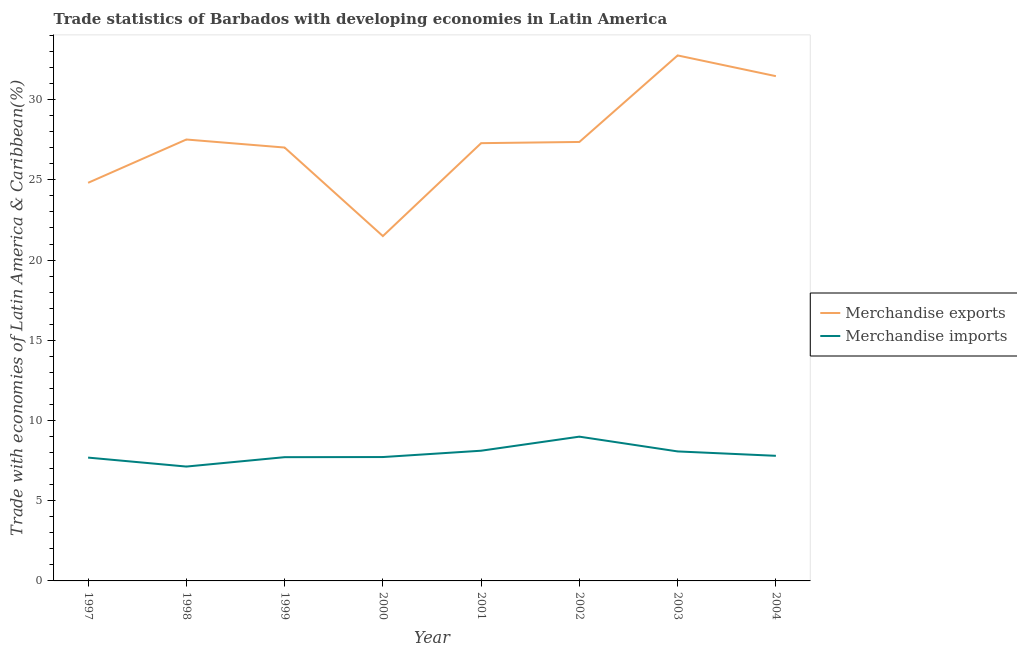What is the merchandise exports in 2001?
Provide a short and direct response. 27.29. Across all years, what is the maximum merchandise imports?
Your answer should be very brief. 8.99. Across all years, what is the minimum merchandise imports?
Keep it short and to the point. 7.13. In which year was the merchandise exports minimum?
Your answer should be very brief. 2000. What is the total merchandise exports in the graph?
Make the answer very short. 219.72. What is the difference between the merchandise imports in 1999 and that in 2004?
Provide a succinct answer. -0.08. What is the difference between the merchandise imports in 1999 and the merchandise exports in 2000?
Make the answer very short. -13.78. What is the average merchandise exports per year?
Offer a very short reply. 27.46. In the year 2002, what is the difference between the merchandise imports and merchandise exports?
Your response must be concise. -18.37. In how many years, is the merchandise exports greater than 21 %?
Provide a succinct answer. 8. What is the ratio of the merchandise imports in 1997 to that in 2004?
Provide a succinct answer. 0.99. Is the merchandise imports in 1997 less than that in 1999?
Make the answer very short. Yes. What is the difference between the highest and the second highest merchandise exports?
Offer a terse response. 1.29. What is the difference between the highest and the lowest merchandise imports?
Keep it short and to the point. 1.86. In how many years, is the merchandise imports greater than the average merchandise imports taken over all years?
Your answer should be compact. 3. Does the merchandise exports monotonically increase over the years?
Provide a short and direct response. No. Is the merchandise exports strictly greater than the merchandise imports over the years?
Offer a terse response. Yes. How many lines are there?
Ensure brevity in your answer.  2. How many years are there in the graph?
Keep it short and to the point. 8. Does the graph contain grids?
Your answer should be compact. No. What is the title of the graph?
Provide a succinct answer. Trade statistics of Barbados with developing economies in Latin America. Does "Food" appear as one of the legend labels in the graph?
Offer a very short reply. No. What is the label or title of the Y-axis?
Offer a very short reply. Trade with economies of Latin America & Caribbean(%). What is the Trade with economies of Latin America & Caribbean(%) in Merchandise exports in 1997?
Your response must be concise. 24.82. What is the Trade with economies of Latin America & Caribbean(%) of Merchandise imports in 1997?
Ensure brevity in your answer.  7.69. What is the Trade with economies of Latin America & Caribbean(%) of Merchandise exports in 1998?
Make the answer very short. 27.52. What is the Trade with economies of Latin America & Caribbean(%) in Merchandise imports in 1998?
Offer a terse response. 7.13. What is the Trade with economies of Latin America & Caribbean(%) in Merchandise exports in 1999?
Offer a very short reply. 27.02. What is the Trade with economies of Latin America & Caribbean(%) of Merchandise imports in 1999?
Provide a short and direct response. 7.71. What is the Trade with economies of Latin America & Caribbean(%) in Merchandise exports in 2000?
Offer a very short reply. 21.5. What is the Trade with economies of Latin America & Caribbean(%) in Merchandise imports in 2000?
Ensure brevity in your answer.  7.72. What is the Trade with economies of Latin America & Caribbean(%) in Merchandise exports in 2001?
Provide a succinct answer. 27.29. What is the Trade with economies of Latin America & Caribbean(%) in Merchandise imports in 2001?
Ensure brevity in your answer.  8.12. What is the Trade with economies of Latin America & Caribbean(%) in Merchandise exports in 2002?
Make the answer very short. 27.36. What is the Trade with economies of Latin America & Caribbean(%) of Merchandise imports in 2002?
Your answer should be compact. 8.99. What is the Trade with economies of Latin America & Caribbean(%) in Merchandise exports in 2003?
Offer a very short reply. 32.76. What is the Trade with economies of Latin America & Caribbean(%) in Merchandise imports in 2003?
Your answer should be very brief. 8.07. What is the Trade with economies of Latin America & Caribbean(%) of Merchandise exports in 2004?
Provide a succinct answer. 31.46. What is the Trade with economies of Latin America & Caribbean(%) of Merchandise imports in 2004?
Your response must be concise. 7.8. Across all years, what is the maximum Trade with economies of Latin America & Caribbean(%) in Merchandise exports?
Provide a short and direct response. 32.76. Across all years, what is the maximum Trade with economies of Latin America & Caribbean(%) of Merchandise imports?
Ensure brevity in your answer.  8.99. Across all years, what is the minimum Trade with economies of Latin America & Caribbean(%) of Merchandise exports?
Keep it short and to the point. 21.5. Across all years, what is the minimum Trade with economies of Latin America & Caribbean(%) in Merchandise imports?
Your answer should be very brief. 7.13. What is the total Trade with economies of Latin America & Caribbean(%) of Merchandise exports in the graph?
Your answer should be compact. 219.72. What is the total Trade with economies of Latin America & Caribbean(%) in Merchandise imports in the graph?
Your answer should be very brief. 63.23. What is the difference between the Trade with economies of Latin America & Caribbean(%) in Merchandise exports in 1997 and that in 1998?
Give a very brief answer. -2.7. What is the difference between the Trade with economies of Latin America & Caribbean(%) of Merchandise imports in 1997 and that in 1998?
Ensure brevity in your answer.  0.56. What is the difference between the Trade with economies of Latin America & Caribbean(%) in Merchandise exports in 1997 and that in 1999?
Provide a short and direct response. -2.2. What is the difference between the Trade with economies of Latin America & Caribbean(%) in Merchandise imports in 1997 and that in 1999?
Offer a very short reply. -0.03. What is the difference between the Trade with economies of Latin America & Caribbean(%) in Merchandise exports in 1997 and that in 2000?
Keep it short and to the point. 3.32. What is the difference between the Trade with economies of Latin America & Caribbean(%) in Merchandise imports in 1997 and that in 2000?
Provide a succinct answer. -0.03. What is the difference between the Trade with economies of Latin America & Caribbean(%) of Merchandise exports in 1997 and that in 2001?
Your answer should be compact. -2.47. What is the difference between the Trade with economies of Latin America & Caribbean(%) in Merchandise imports in 1997 and that in 2001?
Your answer should be compact. -0.43. What is the difference between the Trade with economies of Latin America & Caribbean(%) of Merchandise exports in 1997 and that in 2002?
Ensure brevity in your answer.  -2.55. What is the difference between the Trade with economies of Latin America & Caribbean(%) in Merchandise imports in 1997 and that in 2002?
Provide a succinct answer. -1.31. What is the difference between the Trade with economies of Latin America & Caribbean(%) in Merchandise exports in 1997 and that in 2003?
Make the answer very short. -7.94. What is the difference between the Trade with economies of Latin America & Caribbean(%) of Merchandise imports in 1997 and that in 2003?
Offer a terse response. -0.39. What is the difference between the Trade with economies of Latin America & Caribbean(%) in Merchandise exports in 1997 and that in 2004?
Keep it short and to the point. -6.65. What is the difference between the Trade with economies of Latin America & Caribbean(%) in Merchandise imports in 1997 and that in 2004?
Your answer should be very brief. -0.11. What is the difference between the Trade with economies of Latin America & Caribbean(%) in Merchandise exports in 1998 and that in 1999?
Give a very brief answer. 0.5. What is the difference between the Trade with economies of Latin America & Caribbean(%) in Merchandise imports in 1998 and that in 1999?
Provide a short and direct response. -0.59. What is the difference between the Trade with economies of Latin America & Caribbean(%) of Merchandise exports in 1998 and that in 2000?
Provide a succinct answer. 6.02. What is the difference between the Trade with economies of Latin America & Caribbean(%) in Merchandise imports in 1998 and that in 2000?
Offer a terse response. -0.59. What is the difference between the Trade with economies of Latin America & Caribbean(%) in Merchandise exports in 1998 and that in 2001?
Make the answer very short. 0.23. What is the difference between the Trade with economies of Latin America & Caribbean(%) in Merchandise imports in 1998 and that in 2001?
Make the answer very short. -0.99. What is the difference between the Trade with economies of Latin America & Caribbean(%) in Merchandise exports in 1998 and that in 2002?
Offer a terse response. 0.15. What is the difference between the Trade with economies of Latin America & Caribbean(%) of Merchandise imports in 1998 and that in 2002?
Offer a very short reply. -1.86. What is the difference between the Trade with economies of Latin America & Caribbean(%) in Merchandise exports in 1998 and that in 2003?
Your answer should be very brief. -5.24. What is the difference between the Trade with economies of Latin America & Caribbean(%) of Merchandise imports in 1998 and that in 2003?
Your response must be concise. -0.94. What is the difference between the Trade with economies of Latin America & Caribbean(%) of Merchandise exports in 1998 and that in 2004?
Provide a short and direct response. -3.95. What is the difference between the Trade with economies of Latin America & Caribbean(%) in Merchandise imports in 1998 and that in 2004?
Keep it short and to the point. -0.67. What is the difference between the Trade with economies of Latin America & Caribbean(%) in Merchandise exports in 1999 and that in 2000?
Your response must be concise. 5.52. What is the difference between the Trade with economies of Latin America & Caribbean(%) of Merchandise imports in 1999 and that in 2000?
Provide a short and direct response. -0.01. What is the difference between the Trade with economies of Latin America & Caribbean(%) in Merchandise exports in 1999 and that in 2001?
Provide a short and direct response. -0.27. What is the difference between the Trade with economies of Latin America & Caribbean(%) in Merchandise imports in 1999 and that in 2001?
Offer a terse response. -0.4. What is the difference between the Trade with economies of Latin America & Caribbean(%) in Merchandise exports in 1999 and that in 2002?
Give a very brief answer. -0.35. What is the difference between the Trade with economies of Latin America & Caribbean(%) in Merchandise imports in 1999 and that in 2002?
Keep it short and to the point. -1.28. What is the difference between the Trade with economies of Latin America & Caribbean(%) of Merchandise exports in 1999 and that in 2003?
Make the answer very short. -5.74. What is the difference between the Trade with economies of Latin America & Caribbean(%) of Merchandise imports in 1999 and that in 2003?
Ensure brevity in your answer.  -0.36. What is the difference between the Trade with economies of Latin America & Caribbean(%) in Merchandise exports in 1999 and that in 2004?
Ensure brevity in your answer.  -4.45. What is the difference between the Trade with economies of Latin America & Caribbean(%) of Merchandise imports in 1999 and that in 2004?
Make the answer very short. -0.08. What is the difference between the Trade with economies of Latin America & Caribbean(%) in Merchandise exports in 2000 and that in 2001?
Your answer should be compact. -5.79. What is the difference between the Trade with economies of Latin America & Caribbean(%) of Merchandise imports in 2000 and that in 2001?
Keep it short and to the point. -0.39. What is the difference between the Trade with economies of Latin America & Caribbean(%) of Merchandise exports in 2000 and that in 2002?
Make the answer very short. -5.87. What is the difference between the Trade with economies of Latin America & Caribbean(%) of Merchandise imports in 2000 and that in 2002?
Give a very brief answer. -1.27. What is the difference between the Trade with economies of Latin America & Caribbean(%) in Merchandise exports in 2000 and that in 2003?
Keep it short and to the point. -11.26. What is the difference between the Trade with economies of Latin America & Caribbean(%) of Merchandise imports in 2000 and that in 2003?
Give a very brief answer. -0.35. What is the difference between the Trade with economies of Latin America & Caribbean(%) in Merchandise exports in 2000 and that in 2004?
Your answer should be compact. -9.97. What is the difference between the Trade with economies of Latin America & Caribbean(%) in Merchandise imports in 2000 and that in 2004?
Your answer should be compact. -0.08. What is the difference between the Trade with economies of Latin America & Caribbean(%) in Merchandise exports in 2001 and that in 2002?
Your response must be concise. -0.07. What is the difference between the Trade with economies of Latin America & Caribbean(%) in Merchandise imports in 2001 and that in 2002?
Make the answer very short. -0.88. What is the difference between the Trade with economies of Latin America & Caribbean(%) of Merchandise exports in 2001 and that in 2003?
Provide a short and direct response. -5.47. What is the difference between the Trade with economies of Latin America & Caribbean(%) in Merchandise imports in 2001 and that in 2003?
Offer a very short reply. 0.04. What is the difference between the Trade with economies of Latin America & Caribbean(%) of Merchandise exports in 2001 and that in 2004?
Your answer should be very brief. -4.18. What is the difference between the Trade with economies of Latin America & Caribbean(%) of Merchandise imports in 2001 and that in 2004?
Provide a short and direct response. 0.32. What is the difference between the Trade with economies of Latin America & Caribbean(%) in Merchandise exports in 2002 and that in 2003?
Keep it short and to the point. -5.39. What is the difference between the Trade with economies of Latin America & Caribbean(%) in Merchandise imports in 2002 and that in 2003?
Make the answer very short. 0.92. What is the difference between the Trade with economies of Latin America & Caribbean(%) in Merchandise exports in 2002 and that in 2004?
Give a very brief answer. -4.1. What is the difference between the Trade with economies of Latin America & Caribbean(%) in Merchandise imports in 2002 and that in 2004?
Your answer should be very brief. 1.19. What is the difference between the Trade with economies of Latin America & Caribbean(%) of Merchandise exports in 2003 and that in 2004?
Your response must be concise. 1.29. What is the difference between the Trade with economies of Latin America & Caribbean(%) in Merchandise imports in 2003 and that in 2004?
Keep it short and to the point. 0.27. What is the difference between the Trade with economies of Latin America & Caribbean(%) of Merchandise exports in 1997 and the Trade with economies of Latin America & Caribbean(%) of Merchandise imports in 1998?
Provide a short and direct response. 17.69. What is the difference between the Trade with economies of Latin America & Caribbean(%) of Merchandise exports in 1997 and the Trade with economies of Latin America & Caribbean(%) of Merchandise imports in 1999?
Your response must be concise. 17.1. What is the difference between the Trade with economies of Latin America & Caribbean(%) in Merchandise exports in 1997 and the Trade with economies of Latin America & Caribbean(%) in Merchandise imports in 2000?
Offer a terse response. 17.09. What is the difference between the Trade with economies of Latin America & Caribbean(%) in Merchandise exports in 1997 and the Trade with economies of Latin America & Caribbean(%) in Merchandise imports in 2001?
Offer a terse response. 16.7. What is the difference between the Trade with economies of Latin America & Caribbean(%) in Merchandise exports in 1997 and the Trade with economies of Latin America & Caribbean(%) in Merchandise imports in 2002?
Provide a short and direct response. 15.82. What is the difference between the Trade with economies of Latin America & Caribbean(%) in Merchandise exports in 1997 and the Trade with economies of Latin America & Caribbean(%) in Merchandise imports in 2003?
Your answer should be compact. 16.74. What is the difference between the Trade with economies of Latin America & Caribbean(%) of Merchandise exports in 1997 and the Trade with economies of Latin America & Caribbean(%) of Merchandise imports in 2004?
Offer a very short reply. 17.02. What is the difference between the Trade with economies of Latin America & Caribbean(%) of Merchandise exports in 1998 and the Trade with economies of Latin America & Caribbean(%) of Merchandise imports in 1999?
Your answer should be very brief. 19.8. What is the difference between the Trade with economies of Latin America & Caribbean(%) in Merchandise exports in 1998 and the Trade with economies of Latin America & Caribbean(%) in Merchandise imports in 2000?
Provide a succinct answer. 19.79. What is the difference between the Trade with economies of Latin America & Caribbean(%) of Merchandise exports in 1998 and the Trade with economies of Latin America & Caribbean(%) of Merchandise imports in 2001?
Offer a very short reply. 19.4. What is the difference between the Trade with economies of Latin America & Caribbean(%) in Merchandise exports in 1998 and the Trade with economies of Latin America & Caribbean(%) in Merchandise imports in 2002?
Your answer should be very brief. 18.52. What is the difference between the Trade with economies of Latin America & Caribbean(%) of Merchandise exports in 1998 and the Trade with economies of Latin America & Caribbean(%) of Merchandise imports in 2003?
Your answer should be compact. 19.44. What is the difference between the Trade with economies of Latin America & Caribbean(%) in Merchandise exports in 1998 and the Trade with economies of Latin America & Caribbean(%) in Merchandise imports in 2004?
Your answer should be compact. 19.72. What is the difference between the Trade with economies of Latin America & Caribbean(%) of Merchandise exports in 1999 and the Trade with economies of Latin America & Caribbean(%) of Merchandise imports in 2000?
Your answer should be compact. 19.29. What is the difference between the Trade with economies of Latin America & Caribbean(%) in Merchandise exports in 1999 and the Trade with economies of Latin America & Caribbean(%) in Merchandise imports in 2001?
Offer a very short reply. 18.9. What is the difference between the Trade with economies of Latin America & Caribbean(%) of Merchandise exports in 1999 and the Trade with economies of Latin America & Caribbean(%) of Merchandise imports in 2002?
Provide a succinct answer. 18.02. What is the difference between the Trade with economies of Latin America & Caribbean(%) in Merchandise exports in 1999 and the Trade with economies of Latin America & Caribbean(%) in Merchandise imports in 2003?
Make the answer very short. 18.94. What is the difference between the Trade with economies of Latin America & Caribbean(%) in Merchandise exports in 1999 and the Trade with economies of Latin America & Caribbean(%) in Merchandise imports in 2004?
Provide a short and direct response. 19.22. What is the difference between the Trade with economies of Latin America & Caribbean(%) in Merchandise exports in 2000 and the Trade with economies of Latin America & Caribbean(%) in Merchandise imports in 2001?
Provide a succinct answer. 13.38. What is the difference between the Trade with economies of Latin America & Caribbean(%) in Merchandise exports in 2000 and the Trade with economies of Latin America & Caribbean(%) in Merchandise imports in 2002?
Give a very brief answer. 12.5. What is the difference between the Trade with economies of Latin America & Caribbean(%) of Merchandise exports in 2000 and the Trade with economies of Latin America & Caribbean(%) of Merchandise imports in 2003?
Keep it short and to the point. 13.42. What is the difference between the Trade with economies of Latin America & Caribbean(%) in Merchandise exports in 2000 and the Trade with economies of Latin America & Caribbean(%) in Merchandise imports in 2004?
Your answer should be compact. 13.7. What is the difference between the Trade with economies of Latin America & Caribbean(%) in Merchandise exports in 2001 and the Trade with economies of Latin America & Caribbean(%) in Merchandise imports in 2002?
Your response must be concise. 18.3. What is the difference between the Trade with economies of Latin America & Caribbean(%) of Merchandise exports in 2001 and the Trade with economies of Latin America & Caribbean(%) of Merchandise imports in 2003?
Provide a succinct answer. 19.22. What is the difference between the Trade with economies of Latin America & Caribbean(%) in Merchandise exports in 2001 and the Trade with economies of Latin America & Caribbean(%) in Merchandise imports in 2004?
Keep it short and to the point. 19.49. What is the difference between the Trade with economies of Latin America & Caribbean(%) in Merchandise exports in 2002 and the Trade with economies of Latin America & Caribbean(%) in Merchandise imports in 2003?
Keep it short and to the point. 19.29. What is the difference between the Trade with economies of Latin America & Caribbean(%) of Merchandise exports in 2002 and the Trade with economies of Latin America & Caribbean(%) of Merchandise imports in 2004?
Offer a very short reply. 19.57. What is the difference between the Trade with economies of Latin America & Caribbean(%) of Merchandise exports in 2003 and the Trade with economies of Latin America & Caribbean(%) of Merchandise imports in 2004?
Your response must be concise. 24.96. What is the average Trade with economies of Latin America & Caribbean(%) in Merchandise exports per year?
Give a very brief answer. 27.46. What is the average Trade with economies of Latin America & Caribbean(%) of Merchandise imports per year?
Ensure brevity in your answer.  7.9. In the year 1997, what is the difference between the Trade with economies of Latin America & Caribbean(%) of Merchandise exports and Trade with economies of Latin America & Caribbean(%) of Merchandise imports?
Your response must be concise. 17.13. In the year 1998, what is the difference between the Trade with economies of Latin America & Caribbean(%) of Merchandise exports and Trade with economies of Latin America & Caribbean(%) of Merchandise imports?
Provide a short and direct response. 20.39. In the year 1999, what is the difference between the Trade with economies of Latin America & Caribbean(%) of Merchandise exports and Trade with economies of Latin America & Caribbean(%) of Merchandise imports?
Ensure brevity in your answer.  19.3. In the year 2000, what is the difference between the Trade with economies of Latin America & Caribbean(%) in Merchandise exports and Trade with economies of Latin America & Caribbean(%) in Merchandise imports?
Your response must be concise. 13.77. In the year 2001, what is the difference between the Trade with economies of Latin America & Caribbean(%) in Merchandise exports and Trade with economies of Latin America & Caribbean(%) in Merchandise imports?
Give a very brief answer. 19.17. In the year 2002, what is the difference between the Trade with economies of Latin America & Caribbean(%) in Merchandise exports and Trade with economies of Latin America & Caribbean(%) in Merchandise imports?
Provide a short and direct response. 18.37. In the year 2003, what is the difference between the Trade with economies of Latin America & Caribbean(%) in Merchandise exports and Trade with economies of Latin America & Caribbean(%) in Merchandise imports?
Your answer should be compact. 24.68. In the year 2004, what is the difference between the Trade with economies of Latin America & Caribbean(%) in Merchandise exports and Trade with economies of Latin America & Caribbean(%) in Merchandise imports?
Provide a succinct answer. 23.67. What is the ratio of the Trade with economies of Latin America & Caribbean(%) in Merchandise exports in 1997 to that in 1998?
Give a very brief answer. 0.9. What is the ratio of the Trade with economies of Latin America & Caribbean(%) in Merchandise imports in 1997 to that in 1998?
Make the answer very short. 1.08. What is the ratio of the Trade with economies of Latin America & Caribbean(%) of Merchandise exports in 1997 to that in 1999?
Your answer should be very brief. 0.92. What is the ratio of the Trade with economies of Latin America & Caribbean(%) of Merchandise exports in 1997 to that in 2000?
Keep it short and to the point. 1.15. What is the ratio of the Trade with economies of Latin America & Caribbean(%) in Merchandise exports in 1997 to that in 2001?
Make the answer very short. 0.91. What is the ratio of the Trade with economies of Latin America & Caribbean(%) of Merchandise imports in 1997 to that in 2001?
Your answer should be compact. 0.95. What is the ratio of the Trade with economies of Latin America & Caribbean(%) in Merchandise exports in 1997 to that in 2002?
Offer a terse response. 0.91. What is the ratio of the Trade with economies of Latin America & Caribbean(%) in Merchandise imports in 1997 to that in 2002?
Your answer should be compact. 0.85. What is the ratio of the Trade with economies of Latin America & Caribbean(%) in Merchandise exports in 1997 to that in 2003?
Ensure brevity in your answer.  0.76. What is the ratio of the Trade with economies of Latin America & Caribbean(%) in Merchandise imports in 1997 to that in 2003?
Your answer should be compact. 0.95. What is the ratio of the Trade with economies of Latin America & Caribbean(%) of Merchandise exports in 1997 to that in 2004?
Keep it short and to the point. 0.79. What is the ratio of the Trade with economies of Latin America & Caribbean(%) in Merchandise imports in 1997 to that in 2004?
Offer a terse response. 0.99. What is the ratio of the Trade with economies of Latin America & Caribbean(%) of Merchandise exports in 1998 to that in 1999?
Ensure brevity in your answer.  1.02. What is the ratio of the Trade with economies of Latin America & Caribbean(%) of Merchandise imports in 1998 to that in 1999?
Offer a very short reply. 0.92. What is the ratio of the Trade with economies of Latin America & Caribbean(%) in Merchandise exports in 1998 to that in 2000?
Your answer should be compact. 1.28. What is the ratio of the Trade with economies of Latin America & Caribbean(%) in Merchandise imports in 1998 to that in 2000?
Your response must be concise. 0.92. What is the ratio of the Trade with economies of Latin America & Caribbean(%) of Merchandise exports in 1998 to that in 2001?
Give a very brief answer. 1.01. What is the ratio of the Trade with economies of Latin America & Caribbean(%) in Merchandise imports in 1998 to that in 2001?
Offer a very short reply. 0.88. What is the ratio of the Trade with economies of Latin America & Caribbean(%) in Merchandise exports in 1998 to that in 2002?
Offer a very short reply. 1.01. What is the ratio of the Trade with economies of Latin America & Caribbean(%) of Merchandise imports in 1998 to that in 2002?
Your answer should be compact. 0.79. What is the ratio of the Trade with economies of Latin America & Caribbean(%) in Merchandise exports in 1998 to that in 2003?
Your answer should be compact. 0.84. What is the ratio of the Trade with economies of Latin America & Caribbean(%) of Merchandise imports in 1998 to that in 2003?
Ensure brevity in your answer.  0.88. What is the ratio of the Trade with economies of Latin America & Caribbean(%) of Merchandise exports in 1998 to that in 2004?
Provide a short and direct response. 0.87. What is the ratio of the Trade with economies of Latin America & Caribbean(%) in Merchandise imports in 1998 to that in 2004?
Provide a succinct answer. 0.91. What is the ratio of the Trade with economies of Latin America & Caribbean(%) in Merchandise exports in 1999 to that in 2000?
Your answer should be very brief. 1.26. What is the ratio of the Trade with economies of Latin America & Caribbean(%) of Merchandise exports in 1999 to that in 2001?
Offer a very short reply. 0.99. What is the ratio of the Trade with economies of Latin America & Caribbean(%) in Merchandise imports in 1999 to that in 2001?
Make the answer very short. 0.95. What is the ratio of the Trade with economies of Latin America & Caribbean(%) in Merchandise exports in 1999 to that in 2002?
Provide a succinct answer. 0.99. What is the ratio of the Trade with economies of Latin America & Caribbean(%) in Merchandise imports in 1999 to that in 2002?
Make the answer very short. 0.86. What is the ratio of the Trade with economies of Latin America & Caribbean(%) of Merchandise exports in 1999 to that in 2003?
Your answer should be compact. 0.82. What is the ratio of the Trade with economies of Latin America & Caribbean(%) in Merchandise imports in 1999 to that in 2003?
Offer a very short reply. 0.96. What is the ratio of the Trade with economies of Latin America & Caribbean(%) of Merchandise exports in 1999 to that in 2004?
Provide a succinct answer. 0.86. What is the ratio of the Trade with economies of Latin America & Caribbean(%) of Merchandise exports in 2000 to that in 2001?
Your answer should be very brief. 0.79. What is the ratio of the Trade with economies of Latin America & Caribbean(%) of Merchandise imports in 2000 to that in 2001?
Give a very brief answer. 0.95. What is the ratio of the Trade with economies of Latin America & Caribbean(%) in Merchandise exports in 2000 to that in 2002?
Your answer should be very brief. 0.79. What is the ratio of the Trade with economies of Latin America & Caribbean(%) of Merchandise imports in 2000 to that in 2002?
Ensure brevity in your answer.  0.86. What is the ratio of the Trade with economies of Latin America & Caribbean(%) in Merchandise exports in 2000 to that in 2003?
Your answer should be very brief. 0.66. What is the ratio of the Trade with economies of Latin America & Caribbean(%) in Merchandise imports in 2000 to that in 2003?
Provide a short and direct response. 0.96. What is the ratio of the Trade with economies of Latin America & Caribbean(%) of Merchandise exports in 2000 to that in 2004?
Make the answer very short. 0.68. What is the ratio of the Trade with economies of Latin America & Caribbean(%) of Merchandise imports in 2000 to that in 2004?
Ensure brevity in your answer.  0.99. What is the ratio of the Trade with economies of Latin America & Caribbean(%) of Merchandise exports in 2001 to that in 2002?
Keep it short and to the point. 1. What is the ratio of the Trade with economies of Latin America & Caribbean(%) of Merchandise imports in 2001 to that in 2002?
Ensure brevity in your answer.  0.9. What is the ratio of the Trade with economies of Latin America & Caribbean(%) of Merchandise exports in 2001 to that in 2003?
Provide a succinct answer. 0.83. What is the ratio of the Trade with economies of Latin America & Caribbean(%) of Merchandise exports in 2001 to that in 2004?
Offer a terse response. 0.87. What is the ratio of the Trade with economies of Latin America & Caribbean(%) in Merchandise imports in 2001 to that in 2004?
Give a very brief answer. 1.04. What is the ratio of the Trade with economies of Latin America & Caribbean(%) in Merchandise exports in 2002 to that in 2003?
Give a very brief answer. 0.84. What is the ratio of the Trade with economies of Latin America & Caribbean(%) in Merchandise imports in 2002 to that in 2003?
Your response must be concise. 1.11. What is the ratio of the Trade with economies of Latin America & Caribbean(%) of Merchandise exports in 2002 to that in 2004?
Offer a very short reply. 0.87. What is the ratio of the Trade with economies of Latin America & Caribbean(%) of Merchandise imports in 2002 to that in 2004?
Ensure brevity in your answer.  1.15. What is the ratio of the Trade with economies of Latin America & Caribbean(%) of Merchandise exports in 2003 to that in 2004?
Provide a succinct answer. 1.04. What is the ratio of the Trade with economies of Latin America & Caribbean(%) in Merchandise imports in 2003 to that in 2004?
Your response must be concise. 1.04. What is the difference between the highest and the second highest Trade with economies of Latin America & Caribbean(%) in Merchandise exports?
Make the answer very short. 1.29. What is the difference between the highest and the second highest Trade with economies of Latin America & Caribbean(%) of Merchandise imports?
Your response must be concise. 0.88. What is the difference between the highest and the lowest Trade with economies of Latin America & Caribbean(%) of Merchandise exports?
Offer a terse response. 11.26. What is the difference between the highest and the lowest Trade with economies of Latin America & Caribbean(%) in Merchandise imports?
Provide a short and direct response. 1.86. 